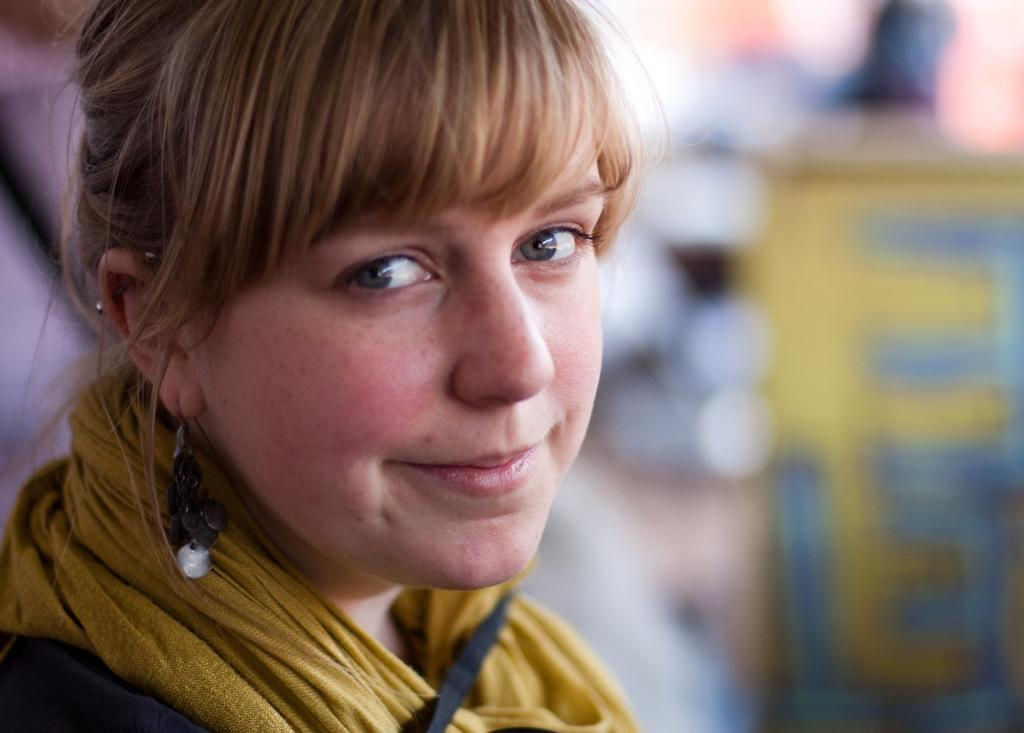Who is the main subject in the image? There is a woman in the image. What is the woman doing in the image? The woman is looking to one side. What type of accessory is the woman wearing? The woman is wearing earrings. What color is the woman's hair? The woman's hair is brown. What sign is the woman holding in the image? There is no sign present in the image; the woman is not holding anything. What time of day is it in the image? The time of day is not mentioned in the image or the provided facts, so it cannot be determined. 